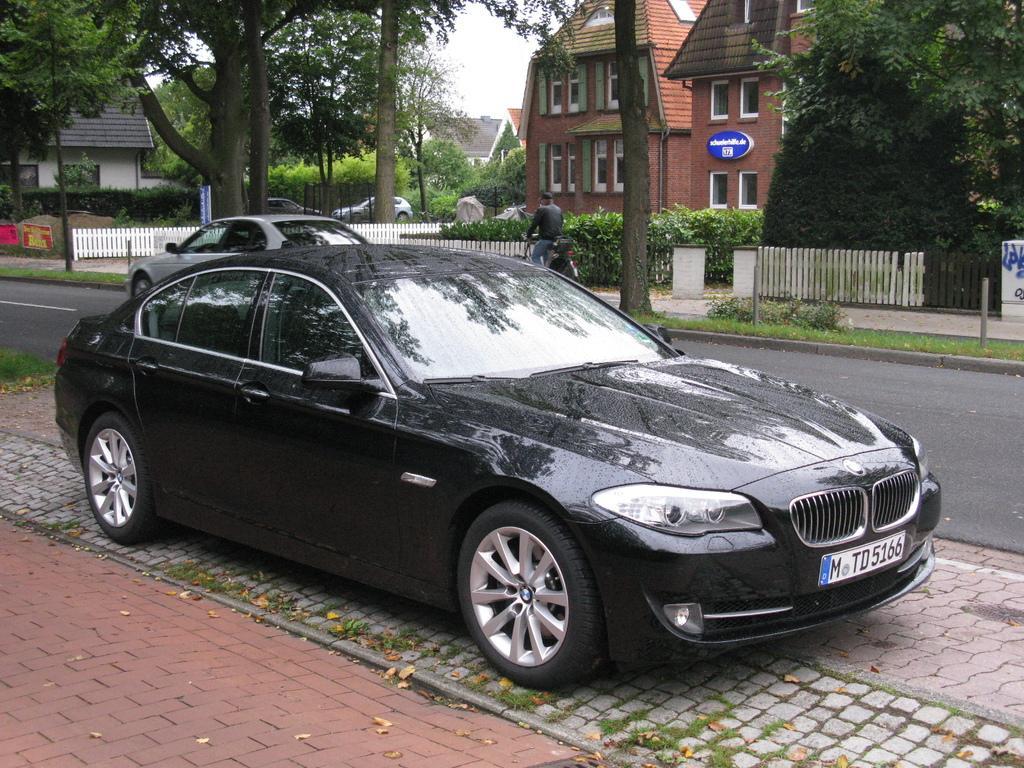Could you give a brief overview of what you see in this image? This image is taken outdoors. At the bottom of the image there is a sidewalk and there is a road. In the background there are a few houses and there are many trees and plants. Two cars are parked on the ground and there are a few wooden fencing. There is a board with a text on it. A man is riding bicycle. In the middle of the image two cars are parked on the road. 